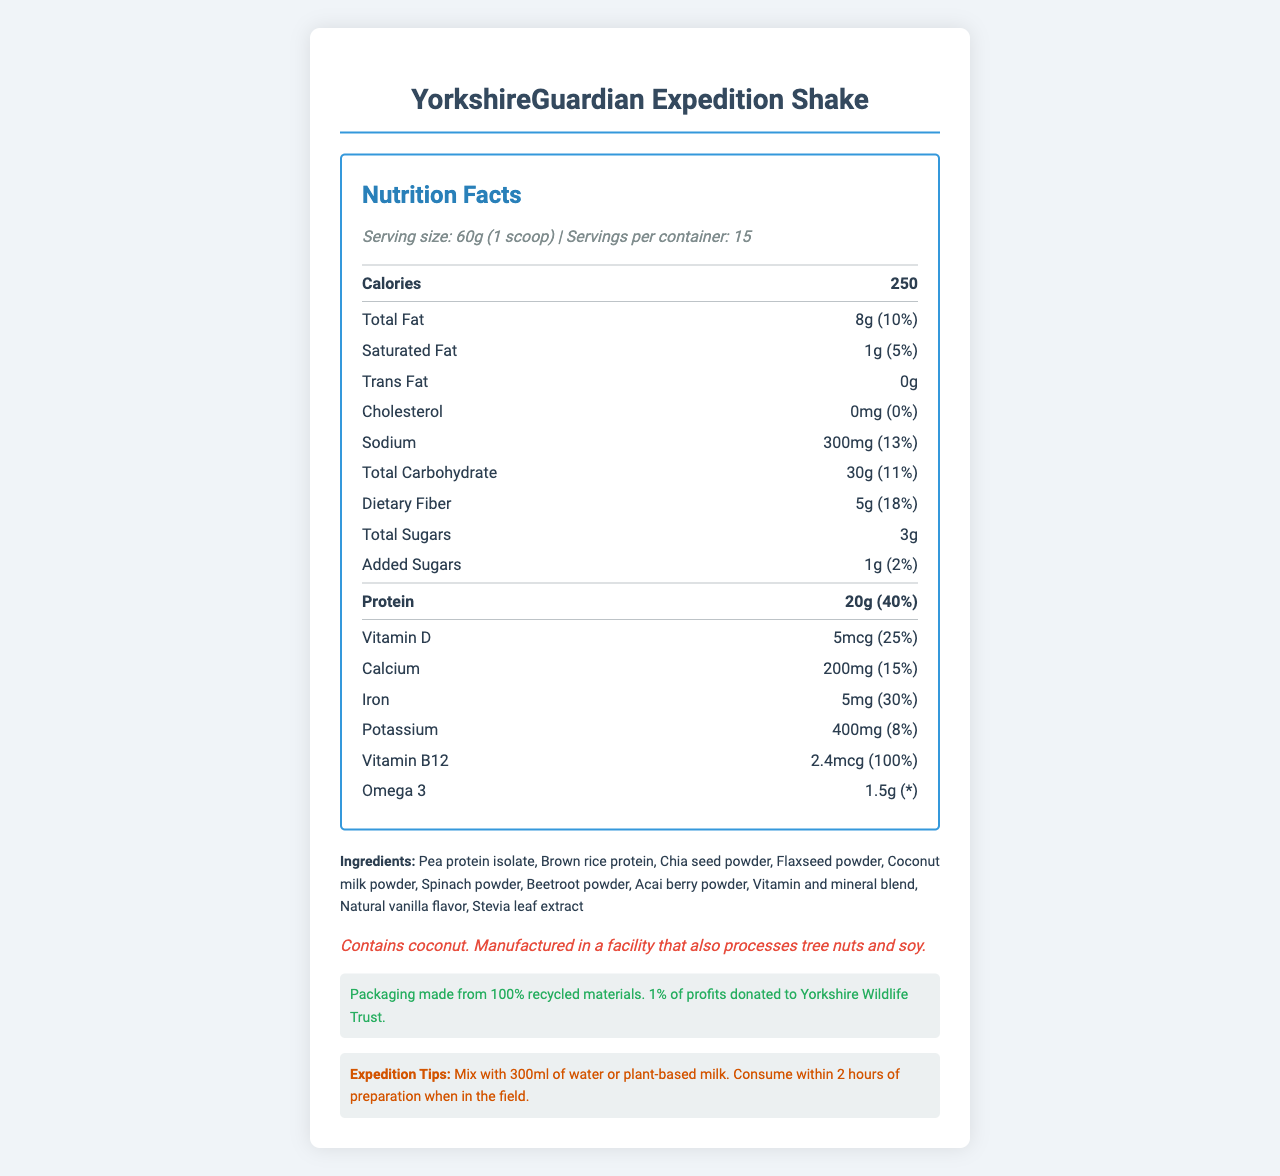how many calories are in one serving of YorkshireGuardian Expedition Shake? The document states that each serving size of the shake has 250 calories.
Answer: 250 how much protein does one serving provide? According to the nutrition label, one serving contains 20 grams of protein.
Answer: 20g What is the serving size for YorkshireGuardian Expedition Shake? The document specifies the serving size as 60g, which is equivalent to 1 scoop.
Answer: 60g (1 scoop) What percentage of the daily value of Vitamin B12 does one serving provide? The document shows that one serving provides 100% of the daily value for Vitamin B12.
Answer: 100% how much dietary fiber is in one serving? The nutritional information indicates that there are 5 grams of dietary fiber per serving.
Answer: 5g Which of the following ingredients is present in the YorkshireGuardian Expedition Shake? A. Soy protein B. Pea Protein Isolate C. Quinoa Flour The list of ingredients includes "Pea Protein Isolate".
Answer: B What is the total fat content per serving? A. 5g B. 8g C. 10g D. 3g The document specifies that each serving contains 8 grams of total fat.
Answer: B Does the shake contain any trans fat? The document states that the shake contains 0 grams of trans fat.
Answer: No Are there any allergens in the YorkshireGuardian Expedition Shake? The document mentions that the shake contains coconut and is manufactured in a facility that processes tree nuts and soy.
Answer: Yes Summarize the main nutritional benefits provided by the YorkshireGuardian Expedition Shake. The document details the shake's high protein (20g per serving), significant daily values of Vitamin D (25%) and B12 (100%), dietary fiber (5g), and its formulation from plant-based ingredients. Additionally, it emphasizes the low sugar content and consideration for expeditions.
Answer: The shake is high in protein, provides key vitamins like Vitamin D and B12, contains dietary fiber, and includes a blend of plant-based ingredients. It supports long expeditions with balanced nutrition while maintaining low sugar content. What is the exact amount of Omega 3 per serving in the YorkshireGuardian Expedition Shake? The nutrition facts state that the shake contains 1.5 grams of Omega 3 per serving.
Answer: 1.5g What percentage of the profits from the YorkshireGuardian Expedition Shake is donated to the Yorkshire Wildlife Trust? According to the conservation note, 1% of profits are donated to the Yorkshire Wildlife Trust.
Answer: 1% What is the sodium content per serving? The document indicates that each serving contains 300mg of sodium.
Answer: 300mg What is the total amount of sugars including added sugars in one serving? The total sugars are 3g, and added sugars are 1g. When combined, they total 4g.
Answer: 4g Can the YorkshireGuardian Expedition Shake replace a full meal for a person on an expedition? The document provides detailed nutritional information but does not state whether it is sufficiently balanced to replace a full meal.
Answer: Cannot be determined 